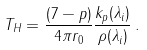<formula> <loc_0><loc_0><loc_500><loc_500>T _ { H } = { \frac { ( 7 - p ) } { 4 \pi r _ { 0 } } } { \frac { k _ { p } ( \lambda _ { i } ) } { \rho ( \lambda _ { i } ) } } \, .</formula> 